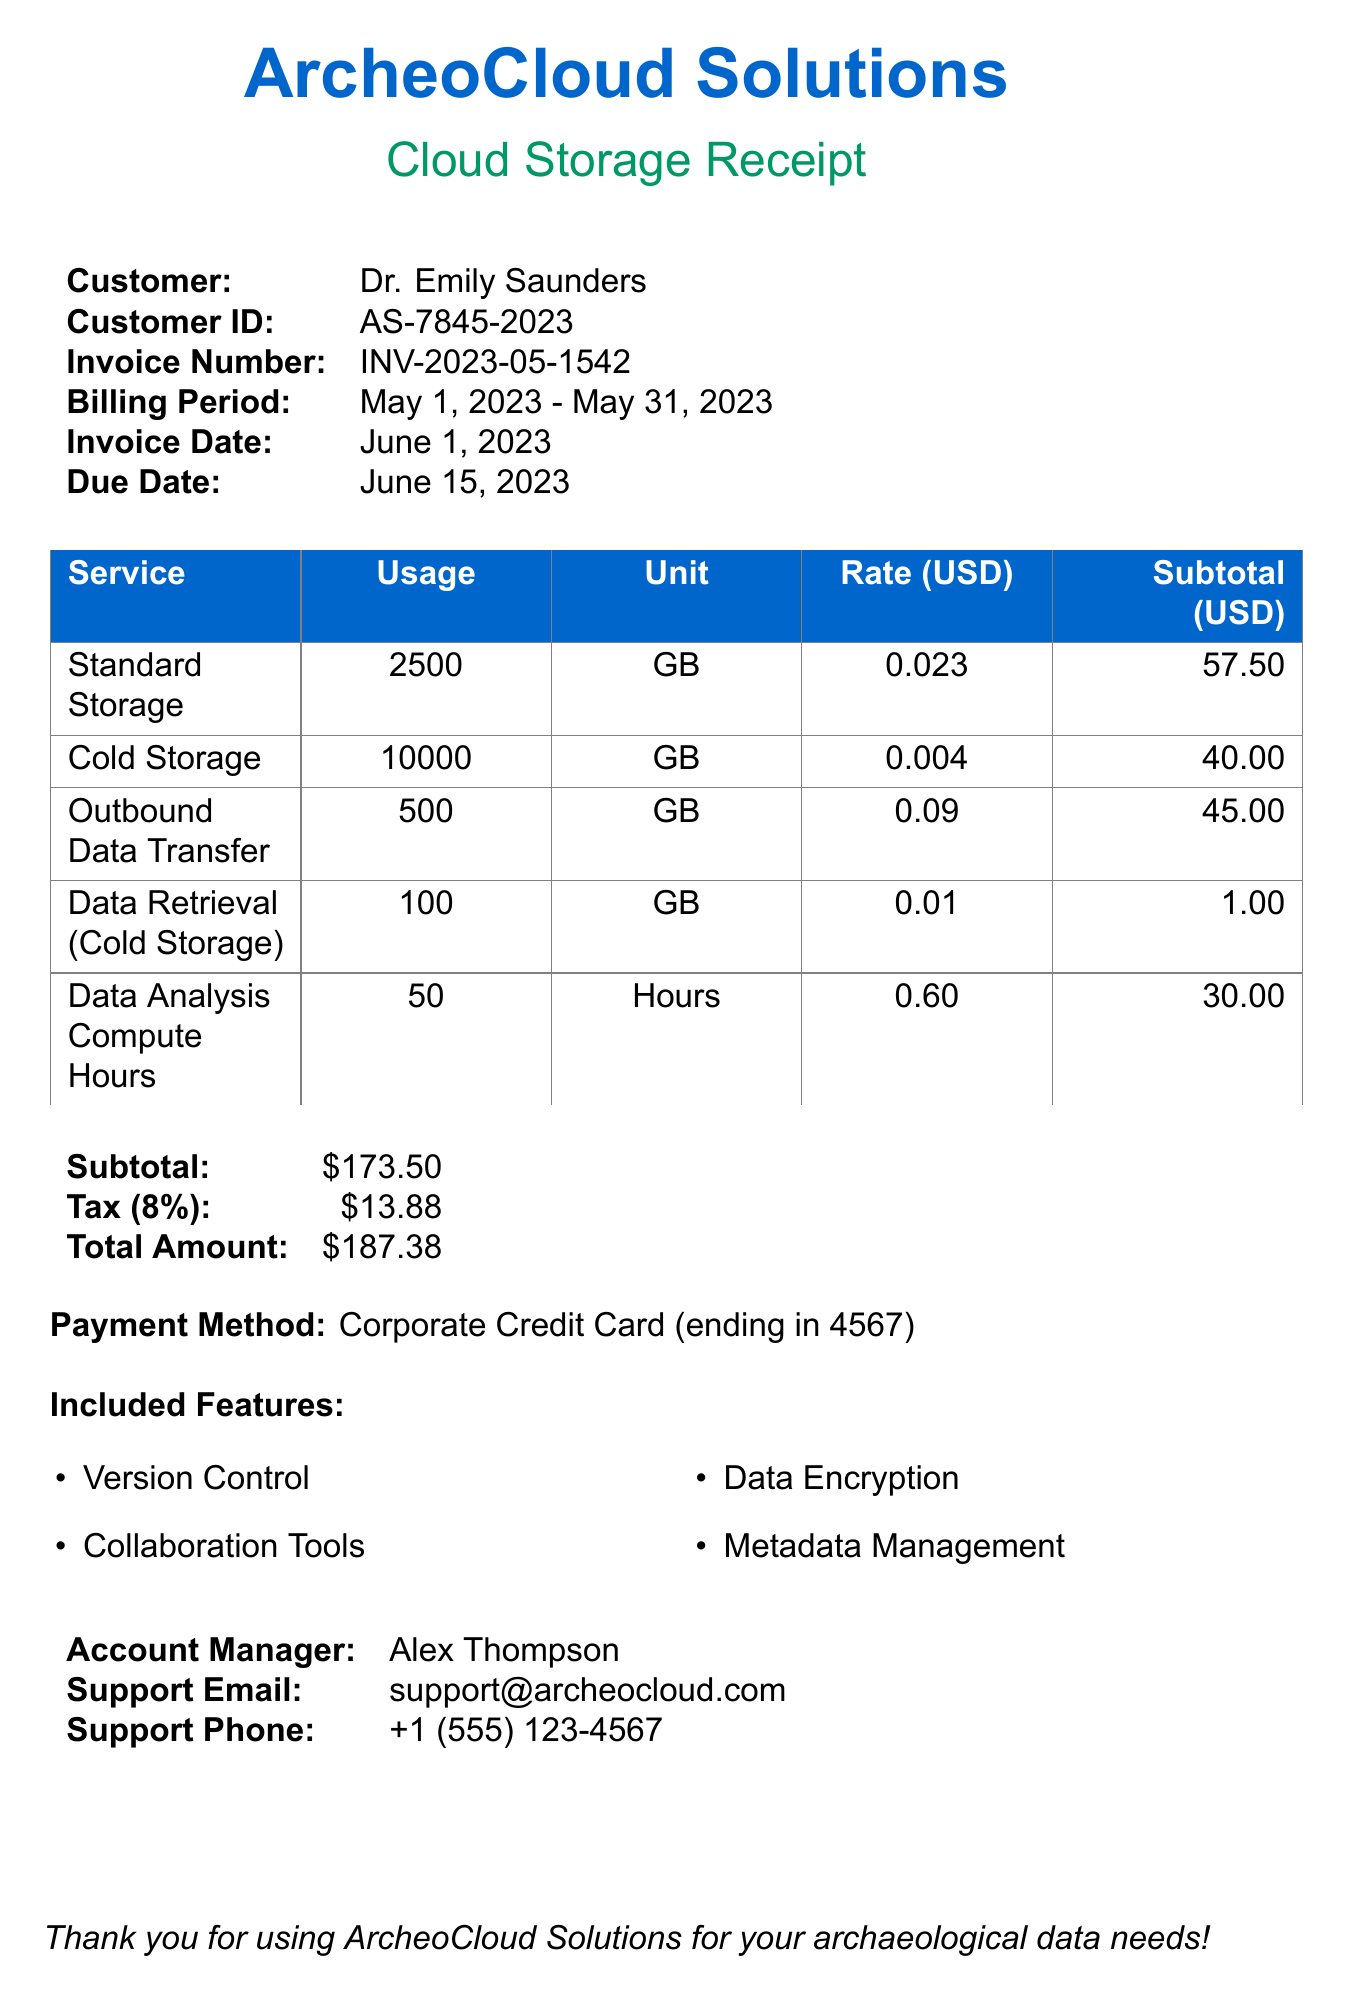What is the customer's name? The customer's name is stated at the top of the receipt.
Answer: Dr. Emily Saunders What is the invoice number? The invoice number is mentioned in the document as part of the billing section.
Answer: INV-2023-05-1542 What is the total amount due? The total amount is calculated as the subtotal plus tax.
Answer: $187.38 How much was charged for outbound data transfer? This charge is specified in the data transfer section of the receipt.
Answer: $45.00 What is the billing period? The billing period is indicated clearly in the receipt.
Answer: May 1, 2023 - May 31, 2023 How many gigabytes of cold storage were used? This information is provided in the storage tiers section.
Answer: 10000 GB What features are included with the service? The included features are listed in a specific section of the document.
Answer: Version Control, Collaboration Tools, Data Encryption, Metadata Management Who is the account manager? The account manager's name is specified towards the end of the document.
Answer: Alex Thompson What is the tax rate applied to the invoice? The tax rate is detailed in the totals section of the document.
Answer: 8% 